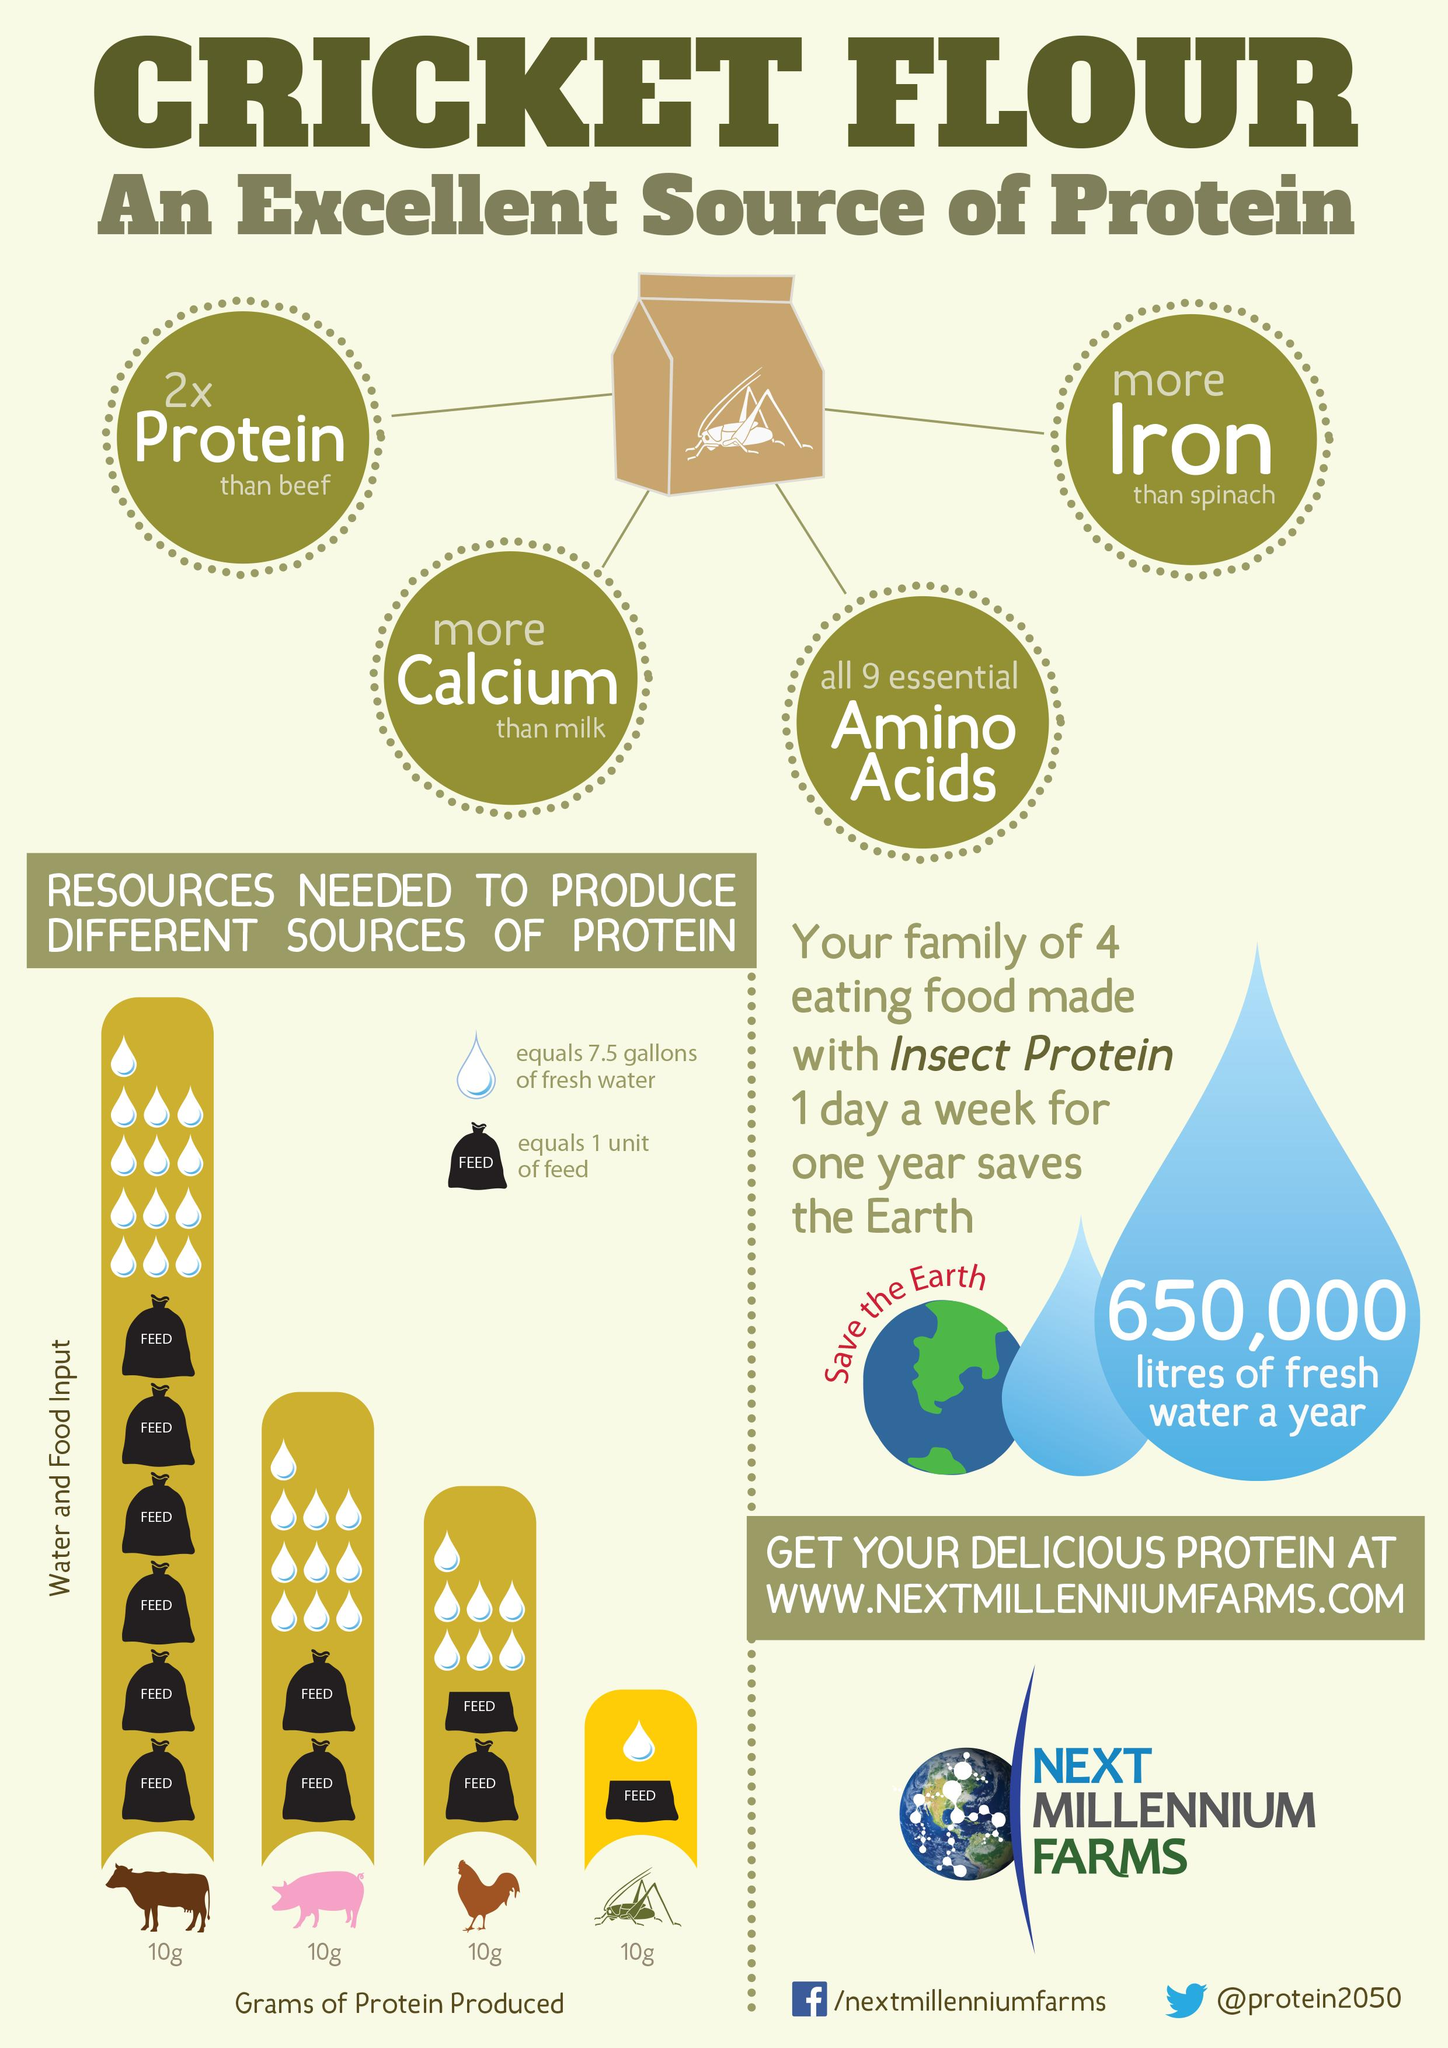Highlight a few significant elements in this photo. This infographic provides information on the essential nutrients found in cricket flour, other than protein, such as calcium, amino acids, and iron. To produce 10 grams of beef protein, 10 gallons of water is needed. To produce 10 grams of insect protein, the amount of water in gallons needed is 7.5. The amount of water needed to produce 10 grams of protein in a pig is 75 gallons. The amount of water needed to produce 10 grams of protein in a rooster is approximately 52.5 liters. 